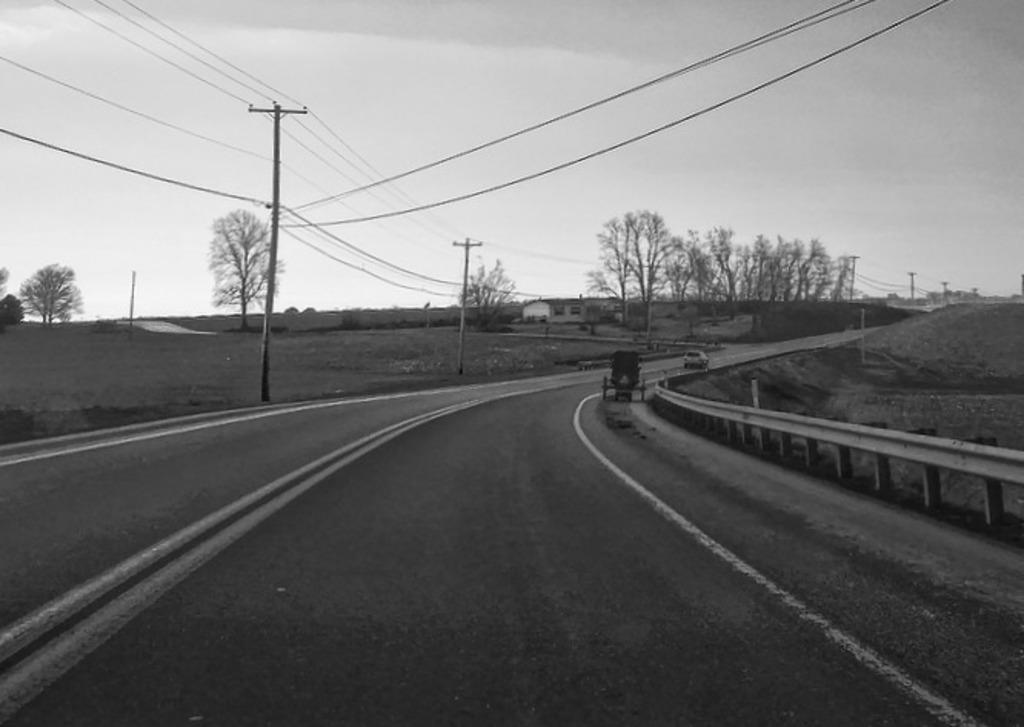In one or two sentences, can you explain what this image depicts? In this black and white image there are two vehicles moving on the road and there are few utility poles, trees, house and the sky. 